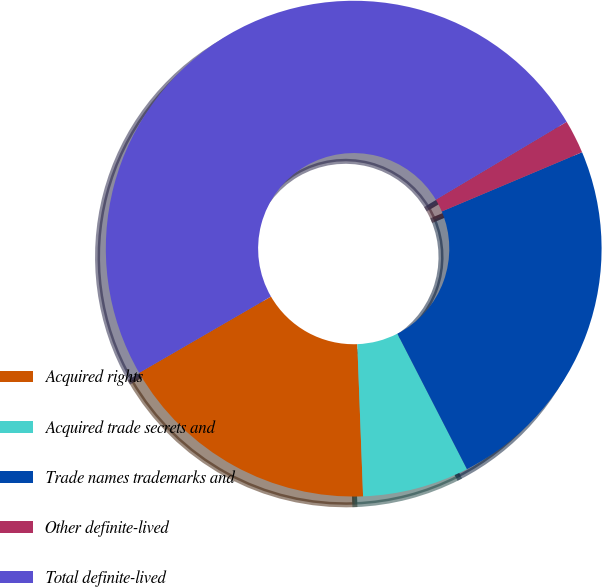Convert chart to OTSL. <chart><loc_0><loc_0><loc_500><loc_500><pie_chart><fcel>Acquired rights<fcel>Acquired trade secrets and<fcel>Trade names trademarks and<fcel>Other definite-lived<fcel>Total definite-lived<nl><fcel>17.25%<fcel>6.95%<fcel>23.81%<fcel>2.19%<fcel>49.81%<nl></chart> 